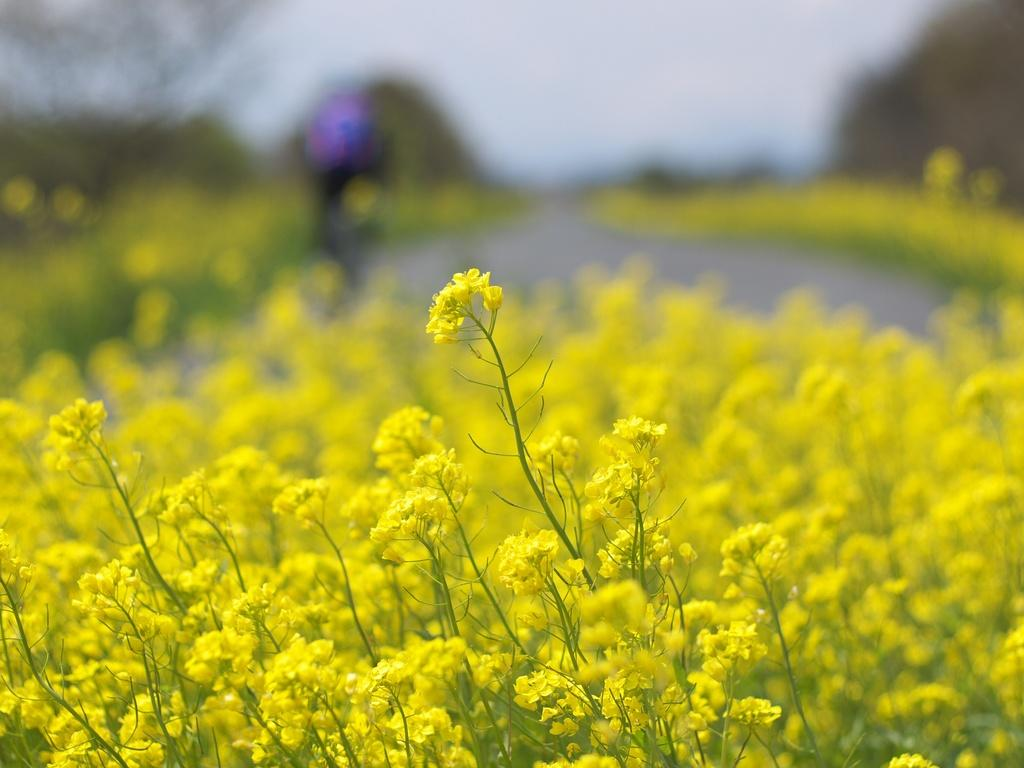What is located at the bottom of the image? There are plants and flowers at the bottom of the image. Can you describe the background of the image? The background of the image is blurred. What type of answer can be seen in the image? There is no answer present in the image; it features plants, flowers, and a blurred background. Is there a girl in the image? There is no mention of a girl in the provided facts, and therefore we cannot confirm her presence in the image. 